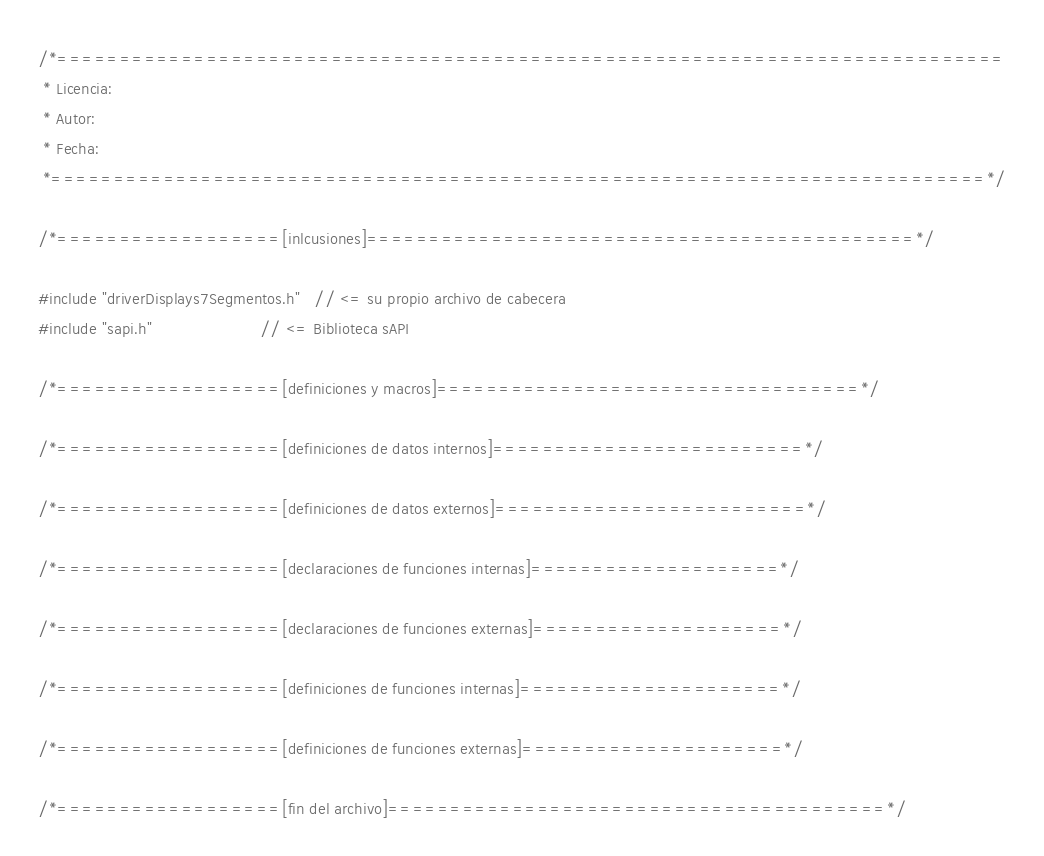<code> <loc_0><loc_0><loc_500><loc_500><_C_>/*============================================================================
 * Licencia: 
 * Autor: 
 * Fecha: 
 *===========================================================================*/

/*==================[inlcusiones]============================================*/

#include "driverDisplays7Segmentos.h"   // <= su propio archivo de cabecera
#include "sapi.h"                       // <= Biblioteca sAPI

/*==================[definiciones y macros]==================================*/

/*==================[definiciones de datos internos]=========================*/

/*==================[definiciones de datos externos]=========================*/

/*==================[declaraciones de funciones internas]====================*/

/*==================[declaraciones de funciones externas]====================*/

/*==================[definiciones de funciones internas]=====================*/

/*==================[definiciones de funciones externas]=====================*/

/*==================[fin del archivo]========================================*/
</code> 